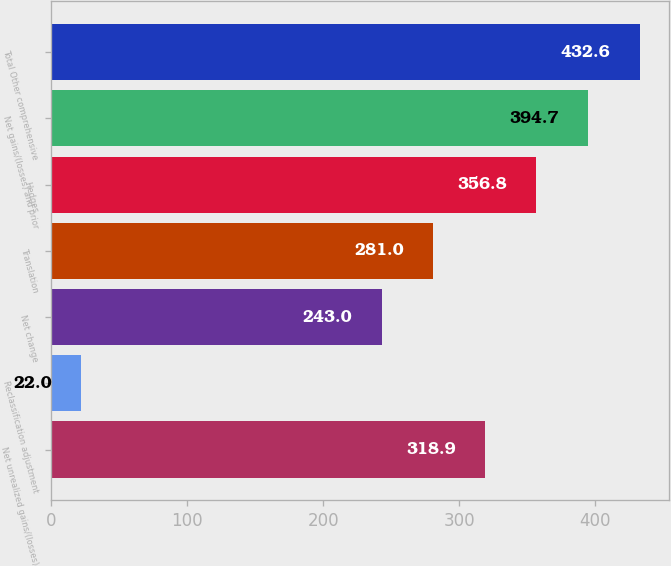<chart> <loc_0><loc_0><loc_500><loc_500><bar_chart><fcel>Net unrealized gains/(losses)<fcel>Reclassification adjustment<fcel>Net change<fcel>Translation<fcel>Hedges<fcel>Net gains/(losses) and prior<fcel>Total Other comprehensive<nl><fcel>318.9<fcel>22<fcel>243<fcel>281<fcel>356.8<fcel>394.7<fcel>432.6<nl></chart> 